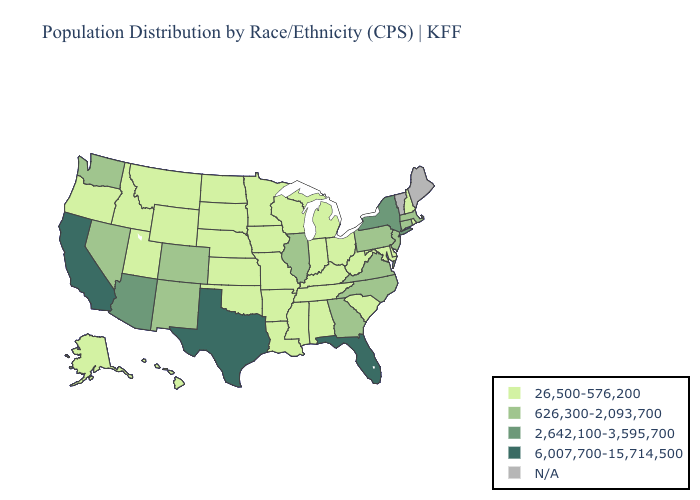What is the value of Arizona?
Short answer required. 2,642,100-3,595,700. What is the lowest value in states that border Alabama?
Keep it brief. 26,500-576,200. Does Georgia have the lowest value in the South?
Write a very short answer. No. Name the states that have a value in the range 626,300-2,093,700?
Write a very short answer. Colorado, Connecticut, Georgia, Illinois, Massachusetts, Nevada, New Jersey, New Mexico, North Carolina, Pennsylvania, Virginia, Washington. What is the value of Oregon?
Be succinct. 26,500-576,200. Among the states that border Arizona , does California have the highest value?
Be succinct. Yes. Name the states that have a value in the range 6,007,700-15,714,500?
Write a very short answer. California, Florida, Texas. What is the lowest value in states that border Iowa?
Answer briefly. 26,500-576,200. What is the value of Alaska?
Short answer required. 26,500-576,200. What is the highest value in the USA?
Be succinct. 6,007,700-15,714,500. What is the value of Mississippi?
Give a very brief answer. 26,500-576,200. What is the value of California?
Give a very brief answer. 6,007,700-15,714,500. How many symbols are there in the legend?
Quick response, please. 5. Name the states that have a value in the range 626,300-2,093,700?
Write a very short answer. Colorado, Connecticut, Georgia, Illinois, Massachusetts, Nevada, New Jersey, New Mexico, North Carolina, Pennsylvania, Virginia, Washington. 